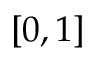<formula> <loc_0><loc_0><loc_500><loc_500>[ 0 , 1 ]</formula> 